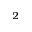Convert formula to latex. <formula><loc_0><loc_0><loc_500><loc_500>^ { 2 }</formula> 